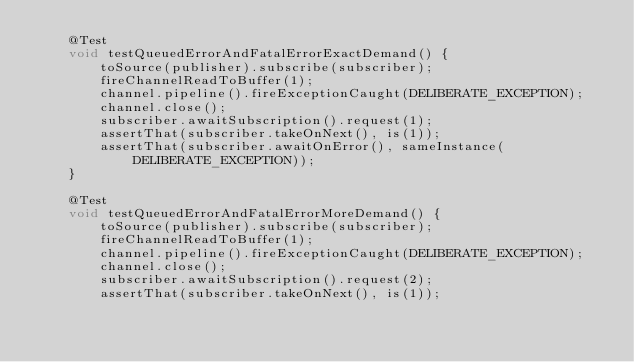<code> <loc_0><loc_0><loc_500><loc_500><_Java_>    @Test
    void testQueuedErrorAndFatalErrorExactDemand() {
        toSource(publisher).subscribe(subscriber);
        fireChannelReadToBuffer(1);
        channel.pipeline().fireExceptionCaught(DELIBERATE_EXCEPTION);
        channel.close();
        subscriber.awaitSubscription().request(1);
        assertThat(subscriber.takeOnNext(), is(1));
        assertThat(subscriber.awaitOnError(), sameInstance(DELIBERATE_EXCEPTION));
    }

    @Test
    void testQueuedErrorAndFatalErrorMoreDemand() {
        toSource(publisher).subscribe(subscriber);
        fireChannelReadToBuffer(1);
        channel.pipeline().fireExceptionCaught(DELIBERATE_EXCEPTION);
        channel.close();
        subscriber.awaitSubscription().request(2);
        assertThat(subscriber.takeOnNext(), is(1));</code> 